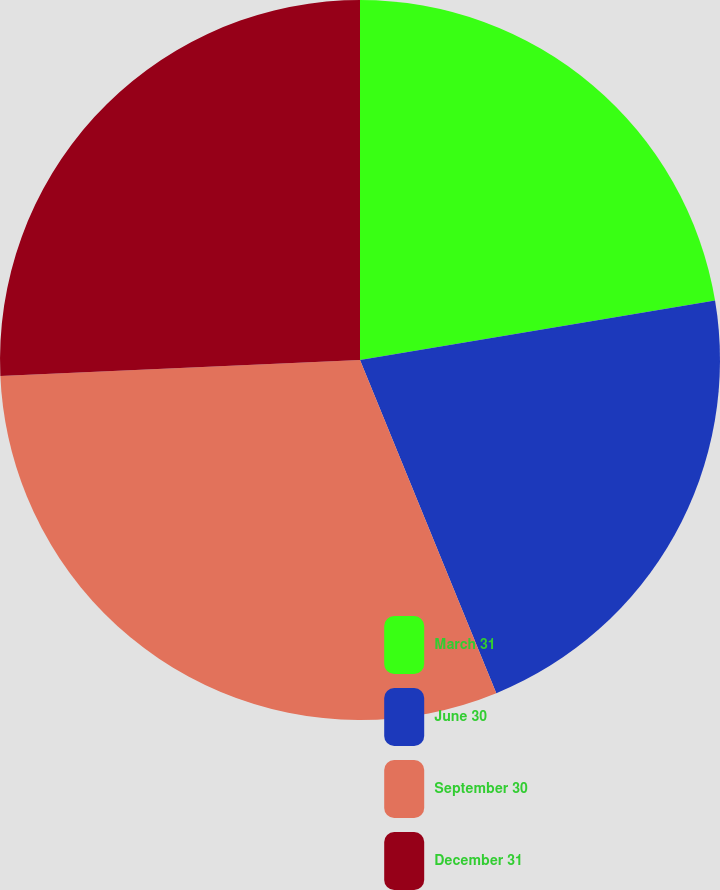Convert chart. <chart><loc_0><loc_0><loc_500><loc_500><pie_chart><fcel>March 31<fcel>June 30<fcel>September 30<fcel>December 31<nl><fcel>22.36%<fcel>21.46%<fcel>30.47%<fcel>25.71%<nl></chart> 